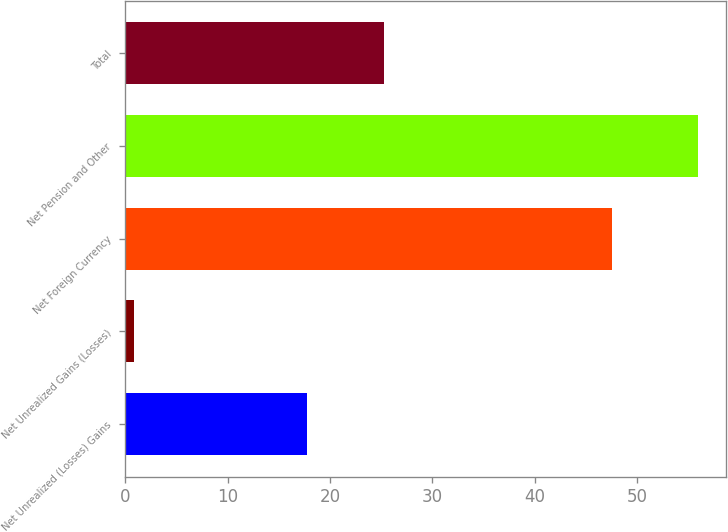Convert chart. <chart><loc_0><loc_0><loc_500><loc_500><bar_chart><fcel>Net Unrealized (Losses) Gains<fcel>Net Unrealized Gains (Losses)<fcel>Net Foreign Currency<fcel>Net Pension and Other<fcel>Total<nl><fcel>17.8<fcel>0.9<fcel>47.5<fcel>55.9<fcel>25.3<nl></chart> 